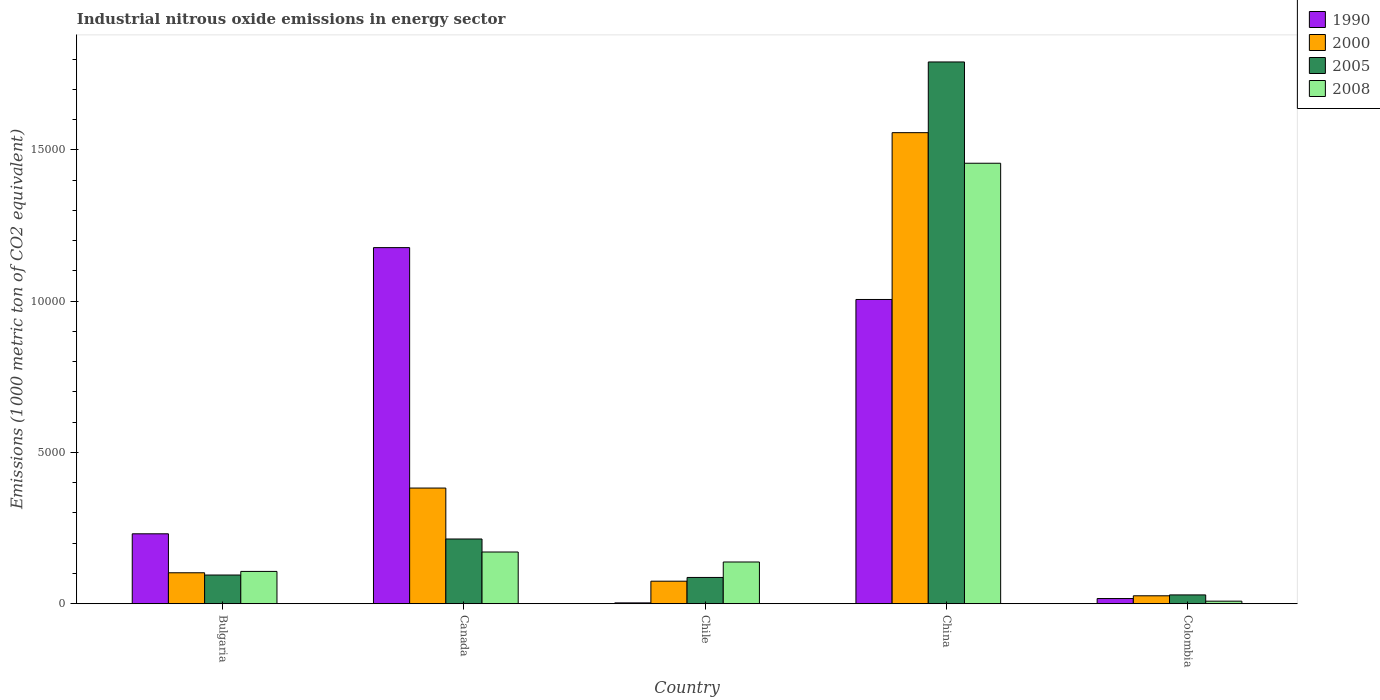How many groups of bars are there?
Your answer should be compact. 5. Are the number of bars per tick equal to the number of legend labels?
Your answer should be very brief. Yes. How many bars are there on the 5th tick from the right?
Your answer should be very brief. 4. What is the label of the 4th group of bars from the left?
Provide a succinct answer. China. In how many cases, is the number of bars for a given country not equal to the number of legend labels?
Provide a succinct answer. 0. What is the amount of industrial nitrous oxide emitted in 1990 in Bulgaria?
Your response must be concise. 2311.2. Across all countries, what is the maximum amount of industrial nitrous oxide emitted in 1990?
Offer a terse response. 1.18e+04. Across all countries, what is the minimum amount of industrial nitrous oxide emitted in 1990?
Ensure brevity in your answer.  27.9. In which country was the amount of industrial nitrous oxide emitted in 2000 minimum?
Your response must be concise. Colombia. What is the total amount of industrial nitrous oxide emitted in 2005 in the graph?
Provide a succinct answer. 2.22e+04. What is the difference between the amount of industrial nitrous oxide emitted in 2008 in Canada and that in Colombia?
Provide a succinct answer. 1624.9. What is the difference between the amount of industrial nitrous oxide emitted in 2008 in Canada and the amount of industrial nitrous oxide emitted in 2000 in Chile?
Give a very brief answer. 964.7. What is the average amount of industrial nitrous oxide emitted in 2005 per country?
Offer a terse response. 4430.96. What is the difference between the amount of industrial nitrous oxide emitted of/in 1990 and amount of industrial nitrous oxide emitted of/in 2005 in Bulgaria?
Make the answer very short. 1362.6. In how many countries, is the amount of industrial nitrous oxide emitted in 2000 greater than 12000 1000 metric ton?
Keep it short and to the point. 1. What is the ratio of the amount of industrial nitrous oxide emitted in 1990 in China to that in Colombia?
Give a very brief answer. 58.6. Is the difference between the amount of industrial nitrous oxide emitted in 1990 in Bulgaria and Chile greater than the difference between the amount of industrial nitrous oxide emitted in 2005 in Bulgaria and Chile?
Provide a short and direct response. Yes. What is the difference between the highest and the second highest amount of industrial nitrous oxide emitted in 2000?
Offer a terse response. 1.45e+04. What is the difference between the highest and the lowest amount of industrial nitrous oxide emitted in 2005?
Offer a terse response. 1.76e+04. Is it the case that in every country, the sum of the amount of industrial nitrous oxide emitted in 1990 and amount of industrial nitrous oxide emitted in 2008 is greater than the sum of amount of industrial nitrous oxide emitted in 2005 and amount of industrial nitrous oxide emitted in 2000?
Your answer should be compact. No. What does the 3rd bar from the right in China represents?
Give a very brief answer. 2000. Is it the case that in every country, the sum of the amount of industrial nitrous oxide emitted in 2008 and amount of industrial nitrous oxide emitted in 1990 is greater than the amount of industrial nitrous oxide emitted in 2000?
Keep it short and to the point. No. Are all the bars in the graph horizontal?
Offer a terse response. No. How many countries are there in the graph?
Give a very brief answer. 5. What is the difference between two consecutive major ticks on the Y-axis?
Make the answer very short. 5000. Does the graph contain any zero values?
Ensure brevity in your answer.  No. Does the graph contain grids?
Your answer should be compact. No. Where does the legend appear in the graph?
Give a very brief answer. Top right. How many legend labels are there?
Provide a succinct answer. 4. What is the title of the graph?
Give a very brief answer. Industrial nitrous oxide emissions in energy sector. What is the label or title of the Y-axis?
Your response must be concise. Emissions (1000 metric ton of CO2 equivalent). What is the Emissions (1000 metric ton of CO2 equivalent) in 1990 in Bulgaria?
Keep it short and to the point. 2311.2. What is the Emissions (1000 metric ton of CO2 equivalent) of 2000 in Bulgaria?
Provide a short and direct response. 1023. What is the Emissions (1000 metric ton of CO2 equivalent) in 2005 in Bulgaria?
Your answer should be very brief. 948.6. What is the Emissions (1000 metric ton of CO2 equivalent) in 2008 in Bulgaria?
Provide a short and direct response. 1068. What is the Emissions (1000 metric ton of CO2 equivalent) in 1990 in Canada?
Offer a very short reply. 1.18e+04. What is the Emissions (1000 metric ton of CO2 equivalent) in 2000 in Canada?
Your response must be concise. 3823.3. What is the Emissions (1000 metric ton of CO2 equivalent) in 2005 in Canada?
Ensure brevity in your answer.  2139.7. What is the Emissions (1000 metric ton of CO2 equivalent) of 2008 in Canada?
Offer a very short reply. 1709.6. What is the Emissions (1000 metric ton of CO2 equivalent) in 1990 in Chile?
Your answer should be compact. 27.9. What is the Emissions (1000 metric ton of CO2 equivalent) in 2000 in Chile?
Your response must be concise. 744.9. What is the Emissions (1000 metric ton of CO2 equivalent) in 2005 in Chile?
Keep it short and to the point. 868.8. What is the Emissions (1000 metric ton of CO2 equivalent) in 2008 in Chile?
Offer a terse response. 1379.7. What is the Emissions (1000 metric ton of CO2 equivalent) of 1990 in China?
Give a very brief answer. 1.01e+04. What is the Emissions (1000 metric ton of CO2 equivalent) of 2000 in China?
Provide a succinct answer. 1.56e+04. What is the Emissions (1000 metric ton of CO2 equivalent) of 2005 in China?
Provide a short and direct response. 1.79e+04. What is the Emissions (1000 metric ton of CO2 equivalent) of 2008 in China?
Make the answer very short. 1.46e+04. What is the Emissions (1000 metric ton of CO2 equivalent) in 1990 in Colombia?
Offer a terse response. 171.6. What is the Emissions (1000 metric ton of CO2 equivalent) in 2000 in Colombia?
Make the answer very short. 262.3. What is the Emissions (1000 metric ton of CO2 equivalent) in 2005 in Colombia?
Keep it short and to the point. 291.3. What is the Emissions (1000 metric ton of CO2 equivalent) in 2008 in Colombia?
Your answer should be very brief. 84.7. Across all countries, what is the maximum Emissions (1000 metric ton of CO2 equivalent) in 1990?
Provide a succinct answer. 1.18e+04. Across all countries, what is the maximum Emissions (1000 metric ton of CO2 equivalent) of 2000?
Give a very brief answer. 1.56e+04. Across all countries, what is the maximum Emissions (1000 metric ton of CO2 equivalent) of 2005?
Keep it short and to the point. 1.79e+04. Across all countries, what is the maximum Emissions (1000 metric ton of CO2 equivalent) of 2008?
Your answer should be compact. 1.46e+04. Across all countries, what is the minimum Emissions (1000 metric ton of CO2 equivalent) in 1990?
Offer a very short reply. 27.9. Across all countries, what is the minimum Emissions (1000 metric ton of CO2 equivalent) in 2000?
Provide a succinct answer. 262.3. Across all countries, what is the minimum Emissions (1000 metric ton of CO2 equivalent) of 2005?
Provide a short and direct response. 291.3. Across all countries, what is the minimum Emissions (1000 metric ton of CO2 equivalent) in 2008?
Keep it short and to the point. 84.7. What is the total Emissions (1000 metric ton of CO2 equivalent) in 1990 in the graph?
Your response must be concise. 2.43e+04. What is the total Emissions (1000 metric ton of CO2 equivalent) of 2000 in the graph?
Ensure brevity in your answer.  2.14e+04. What is the total Emissions (1000 metric ton of CO2 equivalent) of 2005 in the graph?
Keep it short and to the point. 2.22e+04. What is the total Emissions (1000 metric ton of CO2 equivalent) in 2008 in the graph?
Provide a succinct answer. 1.88e+04. What is the difference between the Emissions (1000 metric ton of CO2 equivalent) in 1990 in Bulgaria and that in Canada?
Provide a short and direct response. -9458.8. What is the difference between the Emissions (1000 metric ton of CO2 equivalent) of 2000 in Bulgaria and that in Canada?
Keep it short and to the point. -2800.3. What is the difference between the Emissions (1000 metric ton of CO2 equivalent) in 2005 in Bulgaria and that in Canada?
Ensure brevity in your answer.  -1191.1. What is the difference between the Emissions (1000 metric ton of CO2 equivalent) of 2008 in Bulgaria and that in Canada?
Your response must be concise. -641.6. What is the difference between the Emissions (1000 metric ton of CO2 equivalent) in 1990 in Bulgaria and that in Chile?
Offer a very short reply. 2283.3. What is the difference between the Emissions (1000 metric ton of CO2 equivalent) in 2000 in Bulgaria and that in Chile?
Your answer should be very brief. 278.1. What is the difference between the Emissions (1000 metric ton of CO2 equivalent) in 2005 in Bulgaria and that in Chile?
Your response must be concise. 79.8. What is the difference between the Emissions (1000 metric ton of CO2 equivalent) in 2008 in Bulgaria and that in Chile?
Ensure brevity in your answer.  -311.7. What is the difference between the Emissions (1000 metric ton of CO2 equivalent) in 1990 in Bulgaria and that in China?
Your response must be concise. -7744.9. What is the difference between the Emissions (1000 metric ton of CO2 equivalent) in 2000 in Bulgaria and that in China?
Give a very brief answer. -1.45e+04. What is the difference between the Emissions (1000 metric ton of CO2 equivalent) in 2005 in Bulgaria and that in China?
Your answer should be compact. -1.70e+04. What is the difference between the Emissions (1000 metric ton of CO2 equivalent) in 2008 in Bulgaria and that in China?
Offer a very short reply. -1.35e+04. What is the difference between the Emissions (1000 metric ton of CO2 equivalent) in 1990 in Bulgaria and that in Colombia?
Offer a very short reply. 2139.6. What is the difference between the Emissions (1000 metric ton of CO2 equivalent) in 2000 in Bulgaria and that in Colombia?
Your answer should be very brief. 760.7. What is the difference between the Emissions (1000 metric ton of CO2 equivalent) in 2005 in Bulgaria and that in Colombia?
Keep it short and to the point. 657.3. What is the difference between the Emissions (1000 metric ton of CO2 equivalent) of 2008 in Bulgaria and that in Colombia?
Your answer should be very brief. 983.3. What is the difference between the Emissions (1000 metric ton of CO2 equivalent) in 1990 in Canada and that in Chile?
Offer a very short reply. 1.17e+04. What is the difference between the Emissions (1000 metric ton of CO2 equivalent) of 2000 in Canada and that in Chile?
Keep it short and to the point. 3078.4. What is the difference between the Emissions (1000 metric ton of CO2 equivalent) of 2005 in Canada and that in Chile?
Offer a terse response. 1270.9. What is the difference between the Emissions (1000 metric ton of CO2 equivalent) in 2008 in Canada and that in Chile?
Provide a succinct answer. 329.9. What is the difference between the Emissions (1000 metric ton of CO2 equivalent) of 1990 in Canada and that in China?
Offer a terse response. 1713.9. What is the difference between the Emissions (1000 metric ton of CO2 equivalent) in 2000 in Canada and that in China?
Your response must be concise. -1.17e+04. What is the difference between the Emissions (1000 metric ton of CO2 equivalent) of 2005 in Canada and that in China?
Provide a short and direct response. -1.58e+04. What is the difference between the Emissions (1000 metric ton of CO2 equivalent) of 2008 in Canada and that in China?
Ensure brevity in your answer.  -1.28e+04. What is the difference between the Emissions (1000 metric ton of CO2 equivalent) in 1990 in Canada and that in Colombia?
Your response must be concise. 1.16e+04. What is the difference between the Emissions (1000 metric ton of CO2 equivalent) of 2000 in Canada and that in Colombia?
Provide a short and direct response. 3561. What is the difference between the Emissions (1000 metric ton of CO2 equivalent) in 2005 in Canada and that in Colombia?
Your answer should be compact. 1848.4. What is the difference between the Emissions (1000 metric ton of CO2 equivalent) in 2008 in Canada and that in Colombia?
Make the answer very short. 1624.9. What is the difference between the Emissions (1000 metric ton of CO2 equivalent) in 1990 in Chile and that in China?
Make the answer very short. -1.00e+04. What is the difference between the Emissions (1000 metric ton of CO2 equivalent) of 2000 in Chile and that in China?
Offer a very short reply. -1.48e+04. What is the difference between the Emissions (1000 metric ton of CO2 equivalent) of 2005 in Chile and that in China?
Offer a terse response. -1.70e+04. What is the difference between the Emissions (1000 metric ton of CO2 equivalent) of 2008 in Chile and that in China?
Your response must be concise. -1.32e+04. What is the difference between the Emissions (1000 metric ton of CO2 equivalent) of 1990 in Chile and that in Colombia?
Your response must be concise. -143.7. What is the difference between the Emissions (1000 metric ton of CO2 equivalent) in 2000 in Chile and that in Colombia?
Provide a succinct answer. 482.6. What is the difference between the Emissions (1000 metric ton of CO2 equivalent) in 2005 in Chile and that in Colombia?
Your response must be concise. 577.5. What is the difference between the Emissions (1000 metric ton of CO2 equivalent) in 2008 in Chile and that in Colombia?
Ensure brevity in your answer.  1295. What is the difference between the Emissions (1000 metric ton of CO2 equivalent) in 1990 in China and that in Colombia?
Offer a very short reply. 9884.5. What is the difference between the Emissions (1000 metric ton of CO2 equivalent) in 2000 in China and that in Colombia?
Give a very brief answer. 1.53e+04. What is the difference between the Emissions (1000 metric ton of CO2 equivalent) of 2005 in China and that in Colombia?
Your answer should be very brief. 1.76e+04. What is the difference between the Emissions (1000 metric ton of CO2 equivalent) in 2008 in China and that in Colombia?
Your response must be concise. 1.45e+04. What is the difference between the Emissions (1000 metric ton of CO2 equivalent) in 1990 in Bulgaria and the Emissions (1000 metric ton of CO2 equivalent) in 2000 in Canada?
Keep it short and to the point. -1512.1. What is the difference between the Emissions (1000 metric ton of CO2 equivalent) of 1990 in Bulgaria and the Emissions (1000 metric ton of CO2 equivalent) of 2005 in Canada?
Your response must be concise. 171.5. What is the difference between the Emissions (1000 metric ton of CO2 equivalent) of 1990 in Bulgaria and the Emissions (1000 metric ton of CO2 equivalent) of 2008 in Canada?
Ensure brevity in your answer.  601.6. What is the difference between the Emissions (1000 metric ton of CO2 equivalent) of 2000 in Bulgaria and the Emissions (1000 metric ton of CO2 equivalent) of 2005 in Canada?
Offer a very short reply. -1116.7. What is the difference between the Emissions (1000 metric ton of CO2 equivalent) of 2000 in Bulgaria and the Emissions (1000 metric ton of CO2 equivalent) of 2008 in Canada?
Give a very brief answer. -686.6. What is the difference between the Emissions (1000 metric ton of CO2 equivalent) of 2005 in Bulgaria and the Emissions (1000 metric ton of CO2 equivalent) of 2008 in Canada?
Keep it short and to the point. -761. What is the difference between the Emissions (1000 metric ton of CO2 equivalent) in 1990 in Bulgaria and the Emissions (1000 metric ton of CO2 equivalent) in 2000 in Chile?
Provide a short and direct response. 1566.3. What is the difference between the Emissions (1000 metric ton of CO2 equivalent) in 1990 in Bulgaria and the Emissions (1000 metric ton of CO2 equivalent) in 2005 in Chile?
Offer a very short reply. 1442.4. What is the difference between the Emissions (1000 metric ton of CO2 equivalent) in 1990 in Bulgaria and the Emissions (1000 metric ton of CO2 equivalent) in 2008 in Chile?
Your answer should be compact. 931.5. What is the difference between the Emissions (1000 metric ton of CO2 equivalent) in 2000 in Bulgaria and the Emissions (1000 metric ton of CO2 equivalent) in 2005 in Chile?
Offer a terse response. 154.2. What is the difference between the Emissions (1000 metric ton of CO2 equivalent) in 2000 in Bulgaria and the Emissions (1000 metric ton of CO2 equivalent) in 2008 in Chile?
Offer a terse response. -356.7. What is the difference between the Emissions (1000 metric ton of CO2 equivalent) in 2005 in Bulgaria and the Emissions (1000 metric ton of CO2 equivalent) in 2008 in Chile?
Ensure brevity in your answer.  -431.1. What is the difference between the Emissions (1000 metric ton of CO2 equivalent) in 1990 in Bulgaria and the Emissions (1000 metric ton of CO2 equivalent) in 2000 in China?
Ensure brevity in your answer.  -1.33e+04. What is the difference between the Emissions (1000 metric ton of CO2 equivalent) of 1990 in Bulgaria and the Emissions (1000 metric ton of CO2 equivalent) of 2005 in China?
Provide a short and direct response. -1.56e+04. What is the difference between the Emissions (1000 metric ton of CO2 equivalent) of 1990 in Bulgaria and the Emissions (1000 metric ton of CO2 equivalent) of 2008 in China?
Offer a very short reply. -1.22e+04. What is the difference between the Emissions (1000 metric ton of CO2 equivalent) in 2000 in Bulgaria and the Emissions (1000 metric ton of CO2 equivalent) in 2005 in China?
Keep it short and to the point. -1.69e+04. What is the difference between the Emissions (1000 metric ton of CO2 equivalent) of 2000 in Bulgaria and the Emissions (1000 metric ton of CO2 equivalent) of 2008 in China?
Your answer should be compact. -1.35e+04. What is the difference between the Emissions (1000 metric ton of CO2 equivalent) in 2005 in Bulgaria and the Emissions (1000 metric ton of CO2 equivalent) in 2008 in China?
Keep it short and to the point. -1.36e+04. What is the difference between the Emissions (1000 metric ton of CO2 equivalent) in 1990 in Bulgaria and the Emissions (1000 metric ton of CO2 equivalent) in 2000 in Colombia?
Ensure brevity in your answer.  2048.9. What is the difference between the Emissions (1000 metric ton of CO2 equivalent) in 1990 in Bulgaria and the Emissions (1000 metric ton of CO2 equivalent) in 2005 in Colombia?
Offer a terse response. 2019.9. What is the difference between the Emissions (1000 metric ton of CO2 equivalent) in 1990 in Bulgaria and the Emissions (1000 metric ton of CO2 equivalent) in 2008 in Colombia?
Ensure brevity in your answer.  2226.5. What is the difference between the Emissions (1000 metric ton of CO2 equivalent) of 2000 in Bulgaria and the Emissions (1000 metric ton of CO2 equivalent) of 2005 in Colombia?
Provide a succinct answer. 731.7. What is the difference between the Emissions (1000 metric ton of CO2 equivalent) in 2000 in Bulgaria and the Emissions (1000 metric ton of CO2 equivalent) in 2008 in Colombia?
Offer a terse response. 938.3. What is the difference between the Emissions (1000 metric ton of CO2 equivalent) in 2005 in Bulgaria and the Emissions (1000 metric ton of CO2 equivalent) in 2008 in Colombia?
Keep it short and to the point. 863.9. What is the difference between the Emissions (1000 metric ton of CO2 equivalent) in 1990 in Canada and the Emissions (1000 metric ton of CO2 equivalent) in 2000 in Chile?
Make the answer very short. 1.10e+04. What is the difference between the Emissions (1000 metric ton of CO2 equivalent) of 1990 in Canada and the Emissions (1000 metric ton of CO2 equivalent) of 2005 in Chile?
Give a very brief answer. 1.09e+04. What is the difference between the Emissions (1000 metric ton of CO2 equivalent) of 1990 in Canada and the Emissions (1000 metric ton of CO2 equivalent) of 2008 in Chile?
Provide a succinct answer. 1.04e+04. What is the difference between the Emissions (1000 metric ton of CO2 equivalent) of 2000 in Canada and the Emissions (1000 metric ton of CO2 equivalent) of 2005 in Chile?
Keep it short and to the point. 2954.5. What is the difference between the Emissions (1000 metric ton of CO2 equivalent) in 2000 in Canada and the Emissions (1000 metric ton of CO2 equivalent) in 2008 in Chile?
Keep it short and to the point. 2443.6. What is the difference between the Emissions (1000 metric ton of CO2 equivalent) of 2005 in Canada and the Emissions (1000 metric ton of CO2 equivalent) of 2008 in Chile?
Keep it short and to the point. 760. What is the difference between the Emissions (1000 metric ton of CO2 equivalent) of 1990 in Canada and the Emissions (1000 metric ton of CO2 equivalent) of 2000 in China?
Ensure brevity in your answer.  -3799.7. What is the difference between the Emissions (1000 metric ton of CO2 equivalent) of 1990 in Canada and the Emissions (1000 metric ton of CO2 equivalent) of 2005 in China?
Make the answer very short. -6136.4. What is the difference between the Emissions (1000 metric ton of CO2 equivalent) of 1990 in Canada and the Emissions (1000 metric ton of CO2 equivalent) of 2008 in China?
Your response must be concise. -2788.9. What is the difference between the Emissions (1000 metric ton of CO2 equivalent) in 2000 in Canada and the Emissions (1000 metric ton of CO2 equivalent) in 2005 in China?
Ensure brevity in your answer.  -1.41e+04. What is the difference between the Emissions (1000 metric ton of CO2 equivalent) in 2000 in Canada and the Emissions (1000 metric ton of CO2 equivalent) in 2008 in China?
Ensure brevity in your answer.  -1.07e+04. What is the difference between the Emissions (1000 metric ton of CO2 equivalent) in 2005 in Canada and the Emissions (1000 metric ton of CO2 equivalent) in 2008 in China?
Make the answer very short. -1.24e+04. What is the difference between the Emissions (1000 metric ton of CO2 equivalent) of 1990 in Canada and the Emissions (1000 metric ton of CO2 equivalent) of 2000 in Colombia?
Your answer should be compact. 1.15e+04. What is the difference between the Emissions (1000 metric ton of CO2 equivalent) of 1990 in Canada and the Emissions (1000 metric ton of CO2 equivalent) of 2005 in Colombia?
Keep it short and to the point. 1.15e+04. What is the difference between the Emissions (1000 metric ton of CO2 equivalent) of 1990 in Canada and the Emissions (1000 metric ton of CO2 equivalent) of 2008 in Colombia?
Your answer should be very brief. 1.17e+04. What is the difference between the Emissions (1000 metric ton of CO2 equivalent) in 2000 in Canada and the Emissions (1000 metric ton of CO2 equivalent) in 2005 in Colombia?
Your answer should be very brief. 3532. What is the difference between the Emissions (1000 metric ton of CO2 equivalent) in 2000 in Canada and the Emissions (1000 metric ton of CO2 equivalent) in 2008 in Colombia?
Give a very brief answer. 3738.6. What is the difference between the Emissions (1000 metric ton of CO2 equivalent) of 2005 in Canada and the Emissions (1000 metric ton of CO2 equivalent) of 2008 in Colombia?
Your answer should be very brief. 2055. What is the difference between the Emissions (1000 metric ton of CO2 equivalent) of 1990 in Chile and the Emissions (1000 metric ton of CO2 equivalent) of 2000 in China?
Offer a terse response. -1.55e+04. What is the difference between the Emissions (1000 metric ton of CO2 equivalent) of 1990 in Chile and the Emissions (1000 metric ton of CO2 equivalent) of 2005 in China?
Your answer should be compact. -1.79e+04. What is the difference between the Emissions (1000 metric ton of CO2 equivalent) of 1990 in Chile and the Emissions (1000 metric ton of CO2 equivalent) of 2008 in China?
Keep it short and to the point. -1.45e+04. What is the difference between the Emissions (1000 metric ton of CO2 equivalent) of 2000 in Chile and the Emissions (1000 metric ton of CO2 equivalent) of 2005 in China?
Make the answer very short. -1.72e+04. What is the difference between the Emissions (1000 metric ton of CO2 equivalent) in 2000 in Chile and the Emissions (1000 metric ton of CO2 equivalent) in 2008 in China?
Offer a terse response. -1.38e+04. What is the difference between the Emissions (1000 metric ton of CO2 equivalent) in 2005 in Chile and the Emissions (1000 metric ton of CO2 equivalent) in 2008 in China?
Your answer should be very brief. -1.37e+04. What is the difference between the Emissions (1000 metric ton of CO2 equivalent) of 1990 in Chile and the Emissions (1000 metric ton of CO2 equivalent) of 2000 in Colombia?
Offer a very short reply. -234.4. What is the difference between the Emissions (1000 metric ton of CO2 equivalent) of 1990 in Chile and the Emissions (1000 metric ton of CO2 equivalent) of 2005 in Colombia?
Offer a terse response. -263.4. What is the difference between the Emissions (1000 metric ton of CO2 equivalent) of 1990 in Chile and the Emissions (1000 metric ton of CO2 equivalent) of 2008 in Colombia?
Provide a short and direct response. -56.8. What is the difference between the Emissions (1000 metric ton of CO2 equivalent) of 2000 in Chile and the Emissions (1000 metric ton of CO2 equivalent) of 2005 in Colombia?
Offer a terse response. 453.6. What is the difference between the Emissions (1000 metric ton of CO2 equivalent) of 2000 in Chile and the Emissions (1000 metric ton of CO2 equivalent) of 2008 in Colombia?
Keep it short and to the point. 660.2. What is the difference between the Emissions (1000 metric ton of CO2 equivalent) of 2005 in Chile and the Emissions (1000 metric ton of CO2 equivalent) of 2008 in Colombia?
Keep it short and to the point. 784.1. What is the difference between the Emissions (1000 metric ton of CO2 equivalent) in 1990 in China and the Emissions (1000 metric ton of CO2 equivalent) in 2000 in Colombia?
Provide a short and direct response. 9793.8. What is the difference between the Emissions (1000 metric ton of CO2 equivalent) of 1990 in China and the Emissions (1000 metric ton of CO2 equivalent) of 2005 in Colombia?
Give a very brief answer. 9764.8. What is the difference between the Emissions (1000 metric ton of CO2 equivalent) of 1990 in China and the Emissions (1000 metric ton of CO2 equivalent) of 2008 in Colombia?
Offer a very short reply. 9971.4. What is the difference between the Emissions (1000 metric ton of CO2 equivalent) in 2000 in China and the Emissions (1000 metric ton of CO2 equivalent) in 2005 in Colombia?
Offer a terse response. 1.53e+04. What is the difference between the Emissions (1000 metric ton of CO2 equivalent) in 2000 in China and the Emissions (1000 metric ton of CO2 equivalent) in 2008 in Colombia?
Offer a terse response. 1.55e+04. What is the difference between the Emissions (1000 metric ton of CO2 equivalent) of 2005 in China and the Emissions (1000 metric ton of CO2 equivalent) of 2008 in Colombia?
Make the answer very short. 1.78e+04. What is the average Emissions (1000 metric ton of CO2 equivalent) in 1990 per country?
Provide a succinct answer. 4867.36. What is the average Emissions (1000 metric ton of CO2 equivalent) in 2000 per country?
Offer a very short reply. 4284.64. What is the average Emissions (1000 metric ton of CO2 equivalent) of 2005 per country?
Your response must be concise. 4430.96. What is the average Emissions (1000 metric ton of CO2 equivalent) in 2008 per country?
Keep it short and to the point. 3760.18. What is the difference between the Emissions (1000 metric ton of CO2 equivalent) in 1990 and Emissions (1000 metric ton of CO2 equivalent) in 2000 in Bulgaria?
Your answer should be compact. 1288.2. What is the difference between the Emissions (1000 metric ton of CO2 equivalent) of 1990 and Emissions (1000 metric ton of CO2 equivalent) of 2005 in Bulgaria?
Your answer should be compact. 1362.6. What is the difference between the Emissions (1000 metric ton of CO2 equivalent) of 1990 and Emissions (1000 metric ton of CO2 equivalent) of 2008 in Bulgaria?
Provide a succinct answer. 1243.2. What is the difference between the Emissions (1000 metric ton of CO2 equivalent) of 2000 and Emissions (1000 metric ton of CO2 equivalent) of 2005 in Bulgaria?
Give a very brief answer. 74.4. What is the difference between the Emissions (1000 metric ton of CO2 equivalent) in 2000 and Emissions (1000 metric ton of CO2 equivalent) in 2008 in Bulgaria?
Provide a short and direct response. -45. What is the difference between the Emissions (1000 metric ton of CO2 equivalent) of 2005 and Emissions (1000 metric ton of CO2 equivalent) of 2008 in Bulgaria?
Keep it short and to the point. -119.4. What is the difference between the Emissions (1000 metric ton of CO2 equivalent) in 1990 and Emissions (1000 metric ton of CO2 equivalent) in 2000 in Canada?
Your response must be concise. 7946.7. What is the difference between the Emissions (1000 metric ton of CO2 equivalent) in 1990 and Emissions (1000 metric ton of CO2 equivalent) in 2005 in Canada?
Your response must be concise. 9630.3. What is the difference between the Emissions (1000 metric ton of CO2 equivalent) of 1990 and Emissions (1000 metric ton of CO2 equivalent) of 2008 in Canada?
Offer a very short reply. 1.01e+04. What is the difference between the Emissions (1000 metric ton of CO2 equivalent) in 2000 and Emissions (1000 metric ton of CO2 equivalent) in 2005 in Canada?
Provide a succinct answer. 1683.6. What is the difference between the Emissions (1000 metric ton of CO2 equivalent) of 2000 and Emissions (1000 metric ton of CO2 equivalent) of 2008 in Canada?
Your answer should be compact. 2113.7. What is the difference between the Emissions (1000 metric ton of CO2 equivalent) of 2005 and Emissions (1000 metric ton of CO2 equivalent) of 2008 in Canada?
Give a very brief answer. 430.1. What is the difference between the Emissions (1000 metric ton of CO2 equivalent) of 1990 and Emissions (1000 metric ton of CO2 equivalent) of 2000 in Chile?
Your answer should be compact. -717. What is the difference between the Emissions (1000 metric ton of CO2 equivalent) of 1990 and Emissions (1000 metric ton of CO2 equivalent) of 2005 in Chile?
Your response must be concise. -840.9. What is the difference between the Emissions (1000 metric ton of CO2 equivalent) in 1990 and Emissions (1000 metric ton of CO2 equivalent) in 2008 in Chile?
Provide a succinct answer. -1351.8. What is the difference between the Emissions (1000 metric ton of CO2 equivalent) of 2000 and Emissions (1000 metric ton of CO2 equivalent) of 2005 in Chile?
Your answer should be compact. -123.9. What is the difference between the Emissions (1000 metric ton of CO2 equivalent) in 2000 and Emissions (1000 metric ton of CO2 equivalent) in 2008 in Chile?
Make the answer very short. -634.8. What is the difference between the Emissions (1000 metric ton of CO2 equivalent) of 2005 and Emissions (1000 metric ton of CO2 equivalent) of 2008 in Chile?
Offer a terse response. -510.9. What is the difference between the Emissions (1000 metric ton of CO2 equivalent) of 1990 and Emissions (1000 metric ton of CO2 equivalent) of 2000 in China?
Offer a very short reply. -5513.6. What is the difference between the Emissions (1000 metric ton of CO2 equivalent) in 1990 and Emissions (1000 metric ton of CO2 equivalent) in 2005 in China?
Give a very brief answer. -7850.3. What is the difference between the Emissions (1000 metric ton of CO2 equivalent) in 1990 and Emissions (1000 metric ton of CO2 equivalent) in 2008 in China?
Offer a very short reply. -4502.8. What is the difference between the Emissions (1000 metric ton of CO2 equivalent) in 2000 and Emissions (1000 metric ton of CO2 equivalent) in 2005 in China?
Ensure brevity in your answer.  -2336.7. What is the difference between the Emissions (1000 metric ton of CO2 equivalent) of 2000 and Emissions (1000 metric ton of CO2 equivalent) of 2008 in China?
Keep it short and to the point. 1010.8. What is the difference between the Emissions (1000 metric ton of CO2 equivalent) of 2005 and Emissions (1000 metric ton of CO2 equivalent) of 2008 in China?
Make the answer very short. 3347.5. What is the difference between the Emissions (1000 metric ton of CO2 equivalent) of 1990 and Emissions (1000 metric ton of CO2 equivalent) of 2000 in Colombia?
Your answer should be very brief. -90.7. What is the difference between the Emissions (1000 metric ton of CO2 equivalent) in 1990 and Emissions (1000 metric ton of CO2 equivalent) in 2005 in Colombia?
Provide a succinct answer. -119.7. What is the difference between the Emissions (1000 metric ton of CO2 equivalent) of 1990 and Emissions (1000 metric ton of CO2 equivalent) of 2008 in Colombia?
Give a very brief answer. 86.9. What is the difference between the Emissions (1000 metric ton of CO2 equivalent) in 2000 and Emissions (1000 metric ton of CO2 equivalent) in 2005 in Colombia?
Your response must be concise. -29. What is the difference between the Emissions (1000 metric ton of CO2 equivalent) in 2000 and Emissions (1000 metric ton of CO2 equivalent) in 2008 in Colombia?
Make the answer very short. 177.6. What is the difference between the Emissions (1000 metric ton of CO2 equivalent) of 2005 and Emissions (1000 metric ton of CO2 equivalent) of 2008 in Colombia?
Provide a short and direct response. 206.6. What is the ratio of the Emissions (1000 metric ton of CO2 equivalent) of 1990 in Bulgaria to that in Canada?
Offer a very short reply. 0.2. What is the ratio of the Emissions (1000 metric ton of CO2 equivalent) in 2000 in Bulgaria to that in Canada?
Give a very brief answer. 0.27. What is the ratio of the Emissions (1000 metric ton of CO2 equivalent) of 2005 in Bulgaria to that in Canada?
Your response must be concise. 0.44. What is the ratio of the Emissions (1000 metric ton of CO2 equivalent) of 2008 in Bulgaria to that in Canada?
Offer a terse response. 0.62. What is the ratio of the Emissions (1000 metric ton of CO2 equivalent) in 1990 in Bulgaria to that in Chile?
Provide a short and direct response. 82.84. What is the ratio of the Emissions (1000 metric ton of CO2 equivalent) of 2000 in Bulgaria to that in Chile?
Provide a short and direct response. 1.37. What is the ratio of the Emissions (1000 metric ton of CO2 equivalent) in 2005 in Bulgaria to that in Chile?
Provide a succinct answer. 1.09. What is the ratio of the Emissions (1000 metric ton of CO2 equivalent) in 2008 in Bulgaria to that in Chile?
Make the answer very short. 0.77. What is the ratio of the Emissions (1000 metric ton of CO2 equivalent) in 1990 in Bulgaria to that in China?
Your response must be concise. 0.23. What is the ratio of the Emissions (1000 metric ton of CO2 equivalent) of 2000 in Bulgaria to that in China?
Offer a very short reply. 0.07. What is the ratio of the Emissions (1000 metric ton of CO2 equivalent) of 2005 in Bulgaria to that in China?
Provide a succinct answer. 0.05. What is the ratio of the Emissions (1000 metric ton of CO2 equivalent) of 2008 in Bulgaria to that in China?
Offer a terse response. 0.07. What is the ratio of the Emissions (1000 metric ton of CO2 equivalent) of 1990 in Bulgaria to that in Colombia?
Offer a terse response. 13.47. What is the ratio of the Emissions (1000 metric ton of CO2 equivalent) in 2000 in Bulgaria to that in Colombia?
Make the answer very short. 3.9. What is the ratio of the Emissions (1000 metric ton of CO2 equivalent) of 2005 in Bulgaria to that in Colombia?
Offer a terse response. 3.26. What is the ratio of the Emissions (1000 metric ton of CO2 equivalent) in 2008 in Bulgaria to that in Colombia?
Provide a succinct answer. 12.61. What is the ratio of the Emissions (1000 metric ton of CO2 equivalent) of 1990 in Canada to that in Chile?
Offer a very short reply. 421.86. What is the ratio of the Emissions (1000 metric ton of CO2 equivalent) of 2000 in Canada to that in Chile?
Give a very brief answer. 5.13. What is the ratio of the Emissions (1000 metric ton of CO2 equivalent) of 2005 in Canada to that in Chile?
Give a very brief answer. 2.46. What is the ratio of the Emissions (1000 metric ton of CO2 equivalent) in 2008 in Canada to that in Chile?
Offer a very short reply. 1.24. What is the ratio of the Emissions (1000 metric ton of CO2 equivalent) of 1990 in Canada to that in China?
Keep it short and to the point. 1.17. What is the ratio of the Emissions (1000 metric ton of CO2 equivalent) of 2000 in Canada to that in China?
Provide a succinct answer. 0.25. What is the ratio of the Emissions (1000 metric ton of CO2 equivalent) in 2005 in Canada to that in China?
Your answer should be compact. 0.12. What is the ratio of the Emissions (1000 metric ton of CO2 equivalent) in 2008 in Canada to that in China?
Your response must be concise. 0.12. What is the ratio of the Emissions (1000 metric ton of CO2 equivalent) of 1990 in Canada to that in Colombia?
Your answer should be very brief. 68.59. What is the ratio of the Emissions (1000 metric ton of CO2 equivalent) in 2000 in Canada to that in Colombia?
Make the answer very short. 14.58. What is the ratio of the Emissions (1000 metric ton of CO2 equivalent) in 2005 in Canada to that in Colombia?
Give a very brief answer. 7.35. What is the ratio of the Emissions (1000 metric ton of CO2 equivalent) of 2008 in Canada to that in Colombia?
Keep it short and to the point. 20.18. What is the ratio of the Emissions (1000 metric ton of CO2 equivalent) in 1990 in Chile to that in China?
Offer a terse response. 0. What is the ratio of the Emissions (1000 metric ton of CO2 equivalent) of 2000 in Chile to that in China?
Your answer should be very brief. 0.05. What is the ratio of the Emissions (1000 metric ton of CO2 equivalent) of 2005 in Chile to that in China?
Provide a short and direct response. 0.05. What is the ratio of the Emissions (1000 metric ton of CO2 equivalent) in 2008 in Chile to that in China?
Your answer should be compact. 0.09. What is the ratio of the Emissions (1000 metric ton of CO2 equivalent) in 1990 in Chile to that in Colombia?
Make the answer very short. 0.16. What is the ratio of the Emissions (1000 metric ton of CO2 equivalent) of 2000 in Chile to that in Colombia?
Your answer should be very brief. 2.84. What is the ratio of the Emissions (1000 metric ton of CO2 equivalent) in 2005 in Chile to that in Colombia?
Provide a succinct answer. 2.98. What is the ratio of the Emissions (1000 metric ton of CO2 equivalent) of 2008 in Chile to that in Colombia?
Give a very brief answer. 16.29. What is the ratio of the Emissions (1000 metric ton of CO2 equivalent) of 1990 in China to that in Colombia?
Make the answer very short. 58.6. What is the ratio of the Emissions (1000 metric ton of CO2 equivalent) of 2000 in China to that in Colombia?
Offer a very short reply. 59.36. What is the ratio of the Emissions (1000 metric ton of CO2 equivalent) in 2005 in China to that in Colombia?
Provide a short and direct response. 61.47. What is the ratio of the Emissions (1000 metric ton of CO2 equivalent) in 2008 in China to that in Colombia?
Ensure brevity in your answer.  171.89. What is the difference between the highest and the second highest Emissions (1000 metric ton of CO2 equivalent) of 1990?
Ensure brevity in your answer.  1713.9. What is the difference between the highest and the second highest Emissions (1000 metric ton of CO2 equivalent) of 2000?
Give a very brief answer. 1.17e+04. What is the difference between the highest and the second highest Emissions (1000 metric ton of CO2 equivalent) in 2005?
Your response must be concise. 1.58e+04. What is the difference between the highest and the second highest Emissions (1000 metric ton of CO2 equivalent) in 2008?
Make the answer very short. 1.28e+04. What is the difference between the highest and the lowest Emissions (1000 metric ton of CO2 equivalent) of 1990?
Your response must be concise. 1.17e+04. What is the difference between the highest and the lowest Emissions (1000 metric ton of CO2 equivalent) in 2000?
Provide a succinct answer. 1.53e+04. What is the difference between the highest and the lowest Emissions (1000 metric ton of CO2 equivalent) of 2005?
Keep it short and to the point. 1.76e+04. What is the difference between the highest and the lowest Emissions (1000 metric ton of CO2 equivalent) of 2008?
Offer a terse response. 1.45e+04. 